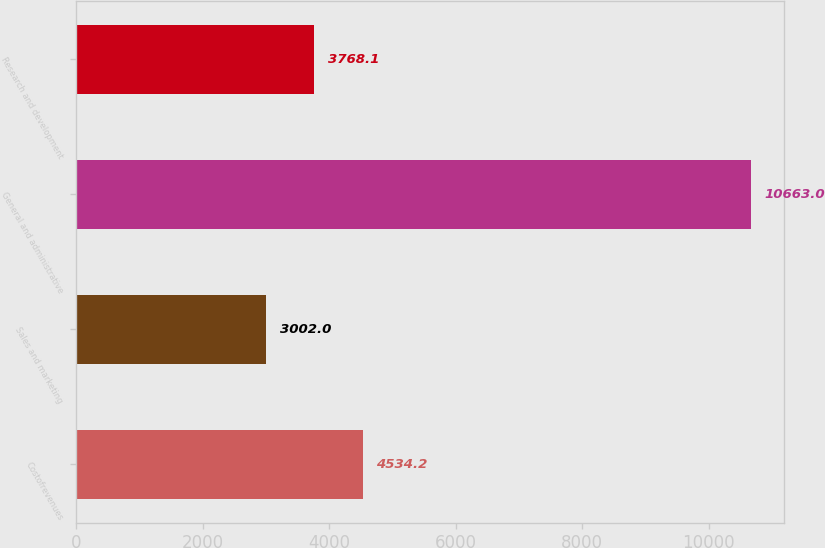Convert chart to OTSL. <chart><loc_0><loc_0><loc_500><loc_500><bar_chart><fcel>Costofrevenues<fcel>Sales and marketing<fcel>General and administrative<fcel>Research and development<nl><fcel>4534.2<fcel>3002<fcel>10663<fcel>3768.1<nl></chart> 